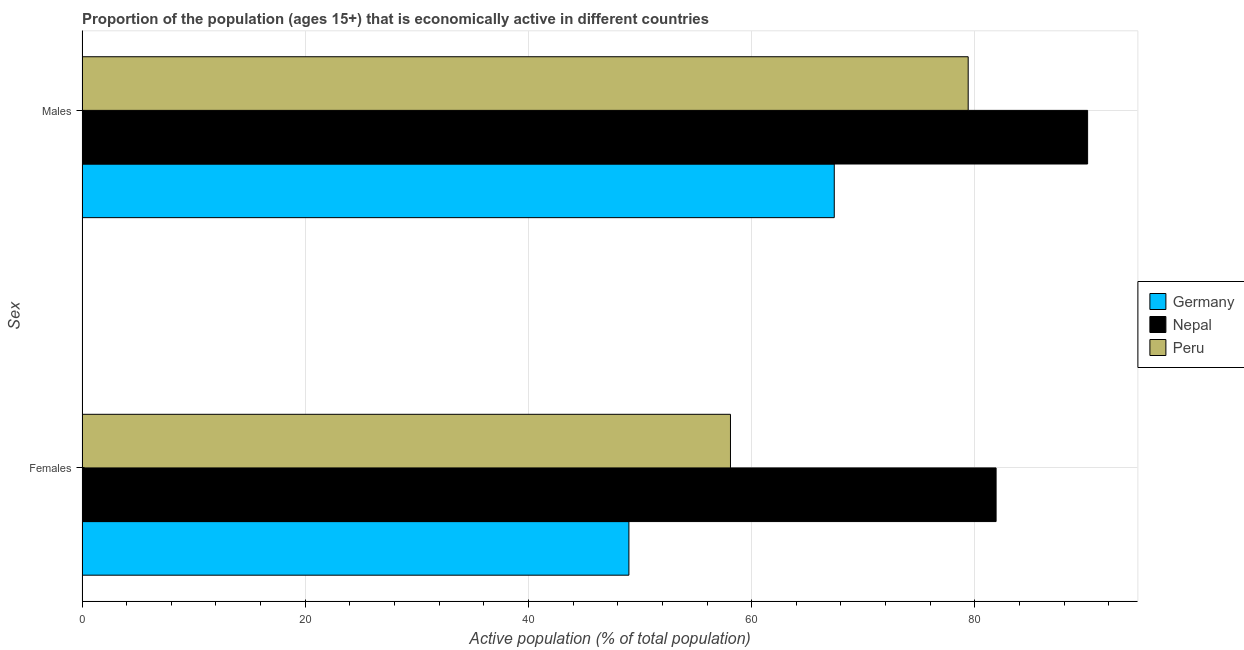How many different coloured bars are there?
Make the answer very short. 3. How many groups of bars are there?
Your response must be concise. 2. Are the number of bars per tick equal to the number of legend labels?
Your answer should be compact. Yes. Are the number of bars on each tick of the Y-axis equal?
Provide a short and direct response. Yes. How many bars are there on the 2nd tick from the top?
Your answer should be compact. 3. What is the label of the 2nd group of bars from the top?
Provide a short and direct response. Females. Across all countries, what is the maximum percentage of economically active male population?
Offer a terse response. 90.1. In which country was the percentage of economically active male population maximum?
Offer a terse response. Nepal. In which country was the percentage of economically active male population minimum?
Provide a succinct answer. Germany. What is the total percentage of economically active male population in the graph?
Offer a terse response. 236.9. What is the difference between the percentage of economically active female population in Germany and that in Peru?
Give a very brief answer. -9.1. What is the difference between the percentage of economically active male population in Germany and the percentage of economically active female population in Nepal?
Provide a succinct answer. -14.5. What is the average percentage of economically active female population per country?
Offer a terse response. 63. What is the difference between the percentage of economically active male population and percentage of economically active female population in Nepal?
Provide a succinct answer. 8.2. What is the ratio of the percentage of economically active female population in Germany to that in Nepal?
Ensure brevity in your answer.  0.6. In how many countries, is the percentage of economically active female population greater than the average percentage of economically active female population taken over all countries?
Offer a terse response. 1. What does the 3rd bar from the top in Females represents?
Offer a terse response. Germany. How many bars are there?
Give a very brief answer. 6. Are all the bars in the graph horizontal?
Give a very brief answer. Yes. Does the graph contain grids?
Provide a short and direct response. Yes. What is the title of the graph?
Offer a very short reply. Proportion of the population (ages 15+) that is economically active in different countries. Does "Botswana" appear as one of the legend labels in the graph?
Make the answer very short. No. What is the label or title of the X-axis?
Your answer should be very brief. Active population (% of total population). What is the label or title of the Y-axis?
Offer a very short reply. Sex. What is the Active population (% of total population) in Germany in Females?
Offer a terse response. 49. What is the Active population (% of total population) of Nepal in Females?
Offer a terse response. 81.9. What is the Active population (% of total population) of Peru in Females?
Offer a very short reply. 58.1. What is the Active population (% of total population) in Germany in Males?
Offer a very short reply. 67.4. What is the Active population (% of total population) of Nepal in Males?
Your answer should be very brief. 90.1. What is the Active population (% of total population) in Peru in Males?
Your response must be concise. 79.4. Across all Sex, what is the maximum Active population (% of total population) in Germany?
Offer a very short reply. 67.4. Across all Sex, what is the maximum Active population (% of total population) in Nepal?
Keep it short and to the point. 90.1. Across all Sex, what is the maximum Active population (% of total population) in Peru?
Your answer should be very brief. 79.4. Across all Sex, what is the minimum Active population (% of total population) of Germany?
Keep it short and to the point. 49. Across all Sex, what is the minimum Active population (% of total population) in Nepal?
Keep it short and to the point. 81.9. Across all Sex, what is the minimum Active population (% of total population) in Peru?
Your response must be concise. 58.1. What is the total Active population (% of total population) in Germany in the graph?
Your answer should be very brief. 116.4. What is the total Active population (% of total population) in Nepal in the graph?
Keep it short and to the point. 172. What is the total Active population (% of total population) in Peru in the graph?
Your answer should be very brief. 137.5. What is the difference between the Active population (% of total population) of Germany in Females and that in Males?
Provide a short and direct response. -18.4. What is the difference between the Active population (% of total population) in Peru in Females and that in Males?
Make the answer very short. -21.3. What is the difference between the Active population (% of total population) in Germany in Females and the Active population (% of total population) in Nepal in Males?
Offer a terse response. -41.1. What is the difference between the Active population (% of total population) of Germany in Females and the Active population (% of total population) of Peru in Males?
Offer a terse response. -30.4. What is the average Active population (% of total population) of Germany per Sex?
Offer a terse response. 58.2. What is the average Active population (% of total population) in Nepal per Sex?
Your answer should be very brief. 86. What is the average Active population (% of total population) in Peru per Sex?
Provide a short and direct response. 68.75. What is the difference between the Active population (% of total population) in Germany and Active population (% of total population) in Nepal in Females?
Provide a short and direct response. -32.9. What is the difference between the Active population (% of total population) in Nepal and Active population (% of total population) in Peru in Females?
Your answer should be very brief. 23.8. What is the difference between the Active population (% of total population) in Germany and Active population (% of total population) in Nepal in Males?
Keep it short and to the point. -22.7. What is the ratio of the Active population (% of total population) in Germany in Females to that in Males?
Your response must be concise. 0.73. What is the ratio of the Active population (% of total population) of Nepal in Females to that in Males?
Offer a terse response. 0.91. What is the ratio of the Active population (% of total population) in Peru in Females to that in Males?
Make the answer very short. 0.73. What is the difference between the highest and the second highest Active population (% of total population) of Peru?
Your answer should be compact. 21.3. What is the difference between the highest and the lowest Active population (% of total population) in Germany?
Offer a very short reply. 18.4. What is the difference between the highest and the lowest Active population (% of total population) of Nepal?
Provide a succinct answer. 8.2. What is the difference between the highest and the lowest Active population (% of total population) in Peru?
Your answer should be very brief. 21.3. 